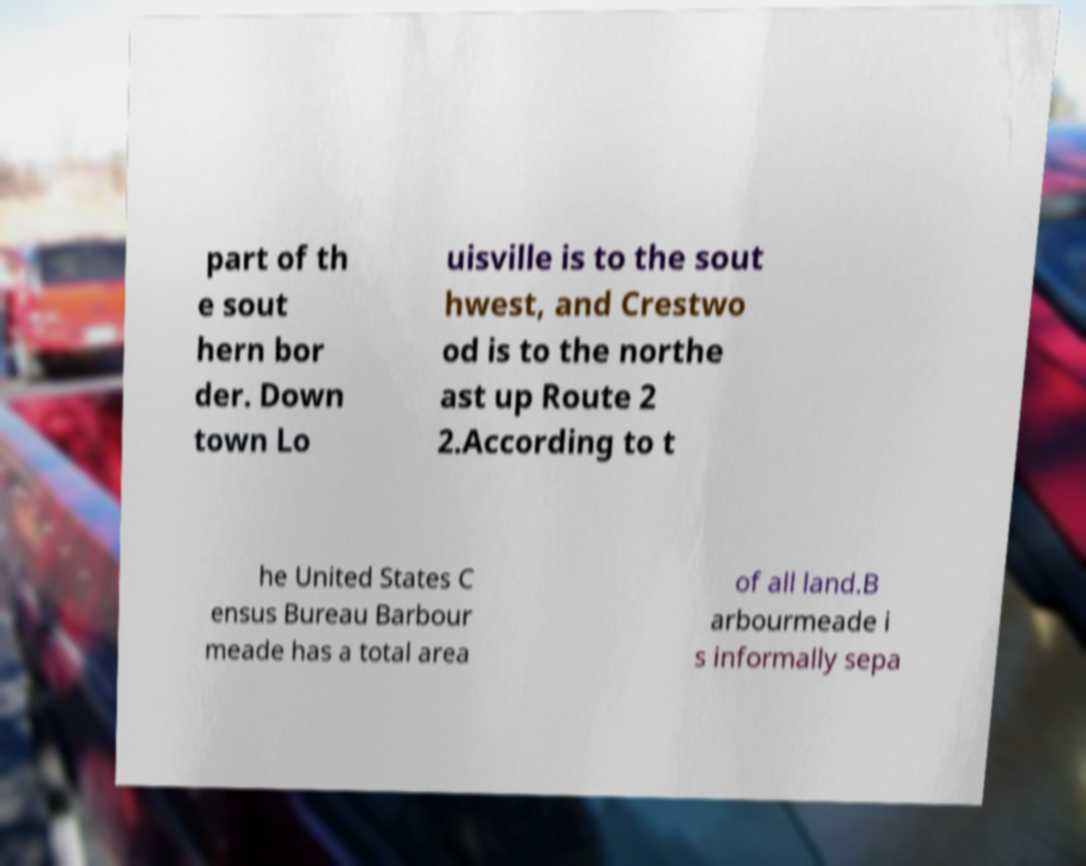There's text embedded in this image that I need extracted. Can you transcribe it verbatim? part of th e sout hern bor der. Down town Lo uisville is to the sout hwest, and Crestwo od is to the northe ast up Route 2 2.According to t he United States C ensus Bureau Barbour meade has a total area of all land.B arbourmeade i s informally sepa 